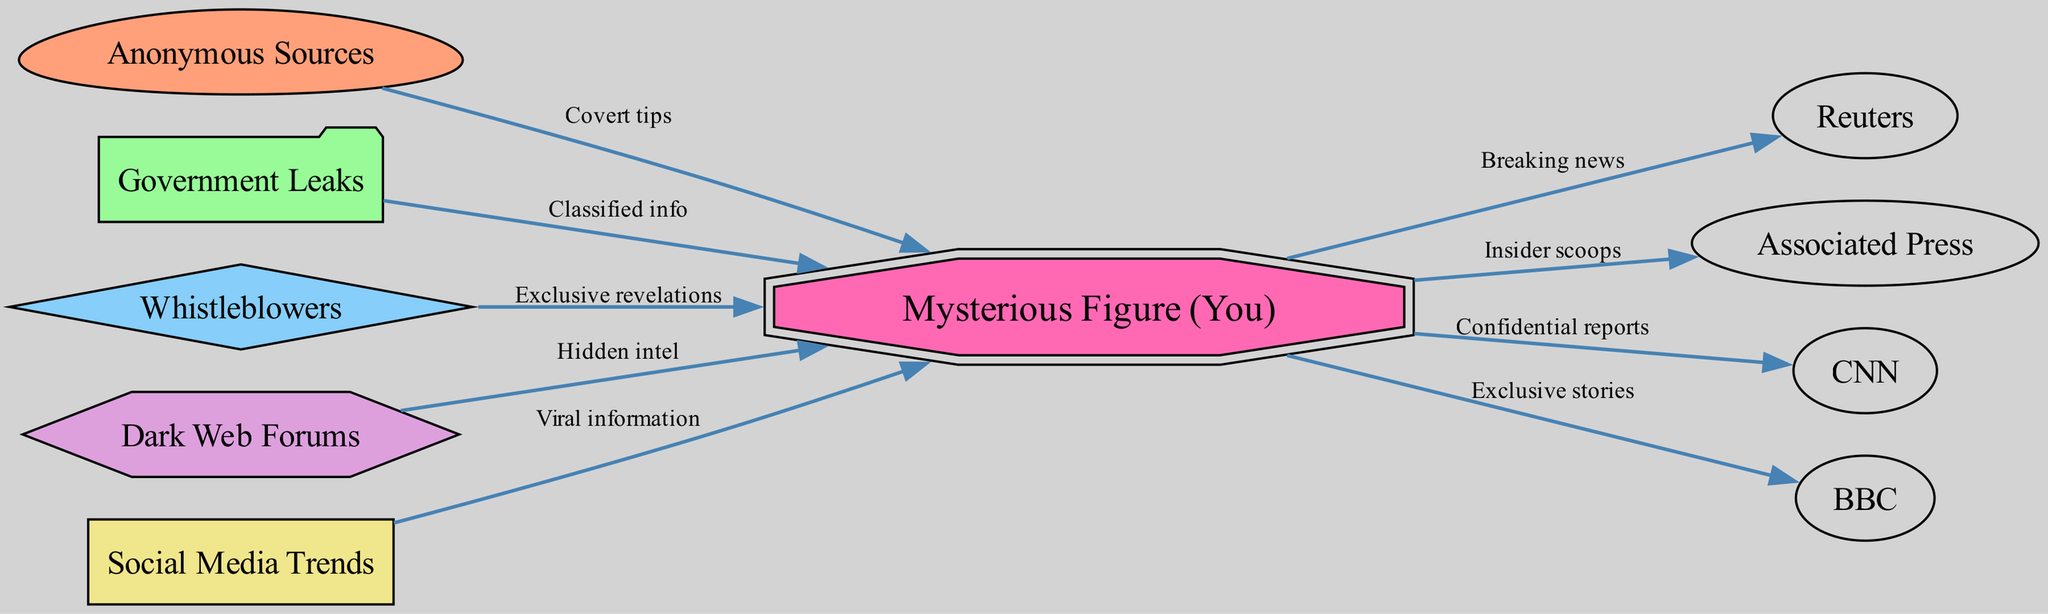What are the types of sources feeding into the mysterious figure? The diagram shows multiple types of sources, including "Anonymous Sources," "Government Leaks," "Whistleblowers," and "Dark Web Forums," which all connect to the "Mysterious Figure." Each of these nodes signifies a different kind of information flow.
Answer: Anonymous Sources, Government Leaks, Whistleblowers, Dark Web Forums How many nodes are there in the diagram? To find the total number of nodes, I count each unique entry in the 'nodes' section of the data. There are 10 distinct nodes listed in the graph.
Answer: 10 What is the label of the node that receives "Confidential reports"? Following the edges originating from the "Mysterious Figure", I see that one of the outputs is directed towards the "CNN" node, which receives "Confidential reports."
Answer: CNN Which source provides "Hidden intel"? I look at the node connections from the "Dark Web Forums" edge, which states that this source sends "Hidden intel" to the "Mysterious Figure." This direct connection indicates where the intel is sourced from.
Answer: Dark Web Forums What is the relationship between "Social Media Trends" and the "Mysterious Figure"? The "Social Media Trends" node points towards the "Mysterious Figure" and indicates that it provides "Viral information." Therefore, the relationship is that "Social Media Trends" feeds viral information to the "Mysterious Figure."
Answer: Viral information 